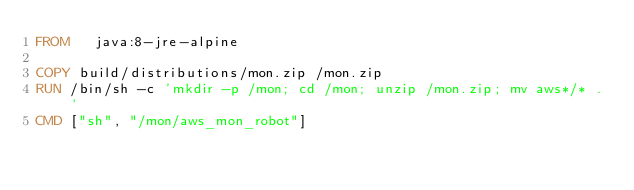Convert code to text. <code><loc_0><loc_0><loc_500><loc_500><_Dockerfile_>FROM   java:8-jre-alpine

COPY build/distributions/mon.zip /mon.zip
RUN /bin/sh -c 'mkdir -p /mon; cd /mon; unzip /mon.zip; mv aws*/* .'
CMD ["sh", "/mon/aws_mon_robot"]
</code> 